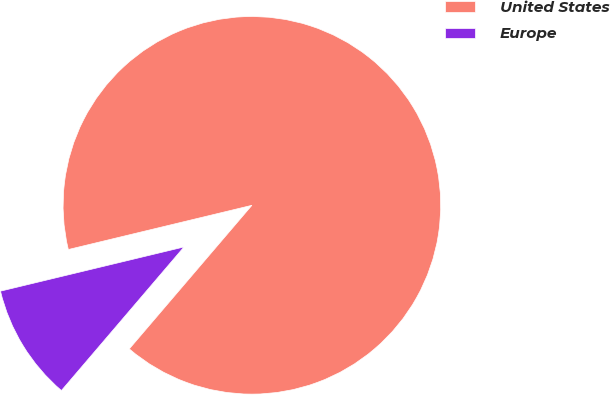Convert chart. <chart><loc_0><loc_0><loc_500><loc_500><pie_chart><fcel>United States<fcel>Europe<nl><fcel>90.01%<fcel>9.99%<nl></chart> 